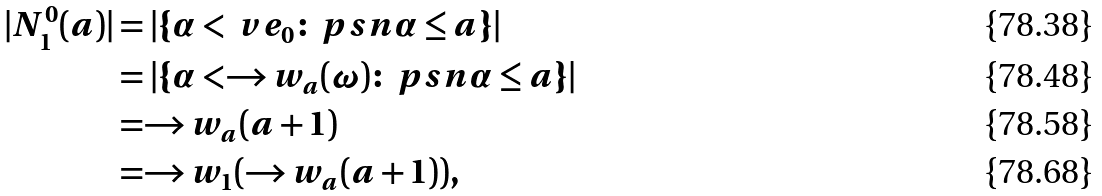Convert formula to latex. <formula><loc_0><loc_0><loc_500><loc_500>| N ^ { 0 } _ { 1 } ( a ) | & = | \{ \alpha < \ v e _ { 0 } \colon \ p s n { \alpha } \leq a \} | \\ & = | \{ \alpha < \to w _ { a } ( \omega ) \colon \ p s n { \alpha } \leq a \} | \\ & = \to w _ { a } ( a + 1 ) \\ & = \to w _ { 1 } ( \to w _ { a } ( a + 1 ) ) ,</formula> 